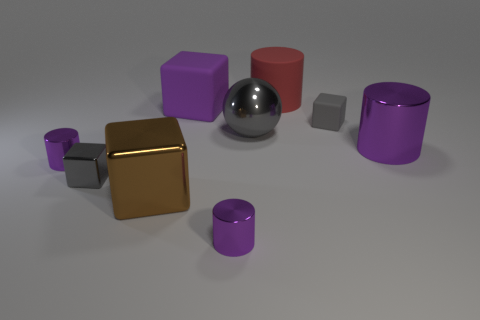What color is the matte cylinder?
Provide a succinct answer. Red. What number of large metallic objects are the same color as the big rubber block?
Provide a succinct answer. 1. There is a purple block that is the same size as the red rubber cylinder; what is its material?
Make the answer very short. Rubber. There is a small block in front of the gray rubber cube; are there any small metal objects in front of it?
Keep it short and to the point. Yes. What number of other things are the same color as the big ball?
Your response must be concise. 2. The gray rubber cube is what size?
Make the answer very short. Small. Are any small gray matte objects visible?
Your answer should be compact. Yes. Are there more red things that are behind the red object than big rubber things left of the big brown shiny object?
Your response must be concise. No. There is a purple cylinder that is to the right of the big matte block and in front of the big purple shiny cylinder; what material is it made of?
Make the answer very short. Metal. Is the shape of the brown metal thing the same as the tiny gray matte object?
Provide a short and direct response. Yes. 